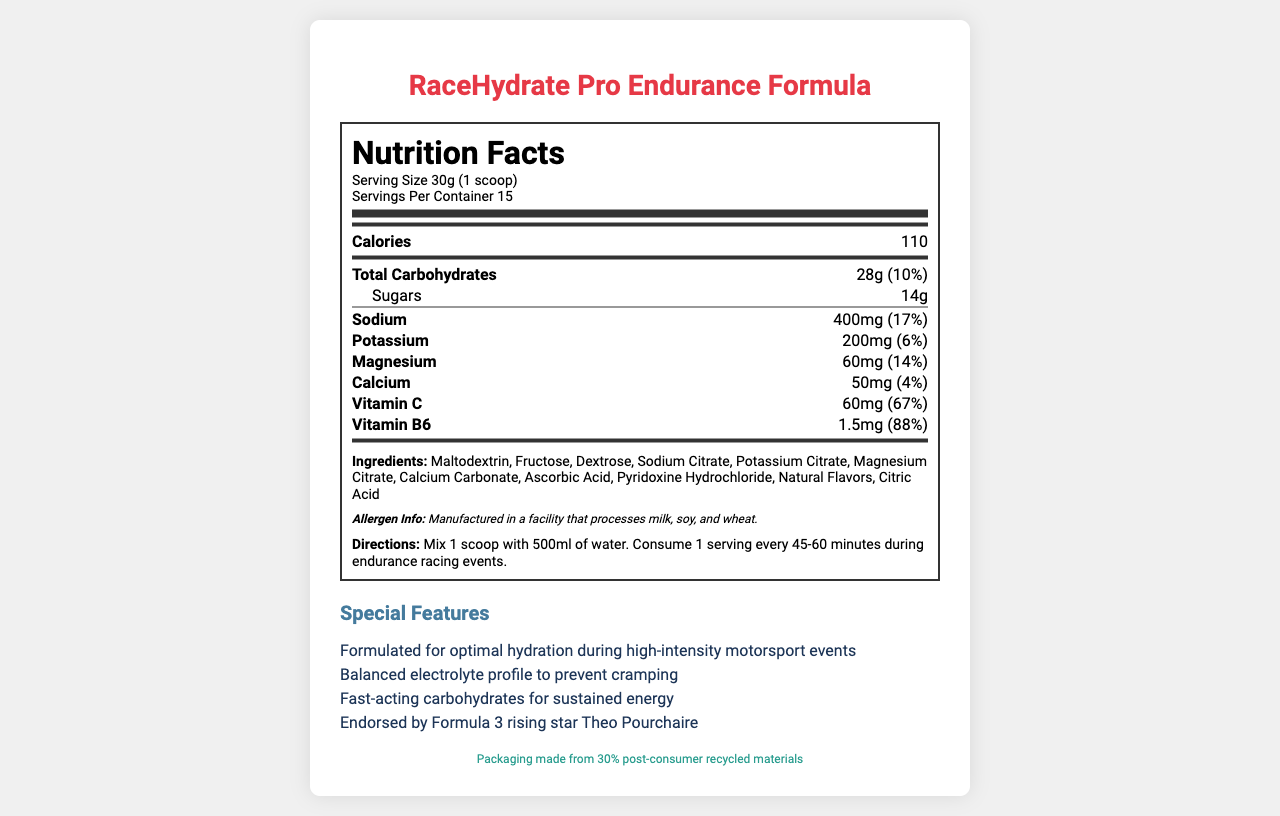what is the serving size? The serving size is clearly mentioned as "30g (1 scoop)" under the nutrition header.
Answer: 30g (1 scoop) How many servings are there per container? It is stated that there are 15 servings per container in the nutrition facts section.
Answer: 15 How many calories are in one serving? The calorie content per serving is listed as 110 in the nutritional information.
Answer: 110 What is the total carbohydrate content per serving? The total carbohydrate amount per serving is mentioned as 28g in the nutrient row section.
Answer: 28g What percentage of the daily value (% DV) is the sodium content per serving? The document states that the sodium content per serving is 400mg, which corresponds to 17% of the daily value.
Answer: 17% Which ingredient is listed first in the ingredients section? The ingredients section lists Maltodextrin as the first ingredient.
Answer: Maltodextrin What special feature is emphasized by being endorsed by a specific athlete? The special features section highlights that the product is endorsed by Formula 3 rising star Theo Pourchaire.
Answer: Endorsed by Formula 3 rising star Theo Pourchaire How much vitamin C is contained in each serving? The amount of vitamin C per serving is listed as 60mg in the nutrient row section.
Answer: 60mg What instructions are given for using the product during endurance racing events? The directions section provides specific instructions on how to use the hydration powder during endurance racing events.
Answer: Mix 1 scoop with 500ml of water. Consume 1 serving every 45-60 minutes during endurance racing events. What material is mentioned regarding the sustainability of the product's packaging? The sustainability info states that the packaging is made from 30% post-consumer recycled materials.
Answer: 30% post-consumer recycled materials Which of the following minerals is NOT listed in the nutritional information? A. Zinc B. Sodium C. Potassium D. Magnesium Sodium, Potassium, and Magnesium are all listed with their respective amounts, but Zinc is not mentioned in the document.
Answer: A. Zinc How many grams of sugar are in each serving of the product? A. 10g B. 12g C. 14g D. 16g The document specifies that there are 14g of sugars per serving.
Answer: C. 14g Is the product free from common allergens like milk, soy, and wheat? The allergen info section states that the product is manufactured in a facility that processes milk, soy, and wheat, indicating it is not free from these allergens.
Answer: No Summarize the main features of the RaceHydrate Pro Endurance Formula. This summary captures the product's essential nutritional details, ingredients, endorsements, and special features.
Answer: The RaceHydrate Pro Endurance Formula is a hydration powder designed for endurance racing events. Each serving size is 30g (1 scoop), and a container has 15 servings. It contains 110 calories, 28g of total carbohydrates, 14g of sugars, 400mg of sodium (17% DV), 200mg of potassium (6% DV), 60mg of magnesium (14% DV), 50mg of calcium (4% DV), 60mg of vitamin C (67% DV), and 1.5mg of vitamin B6 (88% DV). The ingredients include Maltodextrin, Fructose, and several other compounds. The product is endorsed by Formula 3 star Theo Pourchaire and is packaged with 30% post-consumer recycled materials. What is the percentage of protein in each serving? The document does not provide any information regarding the protein content per serving.
Answer: Cannot be determined 